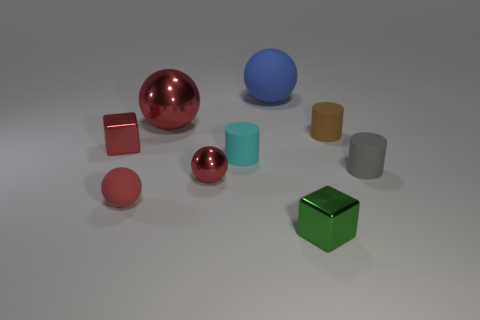Subtract all purple cylinders. How many red balls are left? 3 Add 1 large metal objects. How many objects exist? 10 Subtract all cylinders. How many objects are left? 6 Subtract 0 yellow blocks. How many objects are left? 9 Subtract all tiny gray cylinders. Subtract all cubes. How many objects are left? 6 Add 1 red metal balls. How many red metal balls are left? 3 Add 4 red blocks. How many red blocks exist? 5 